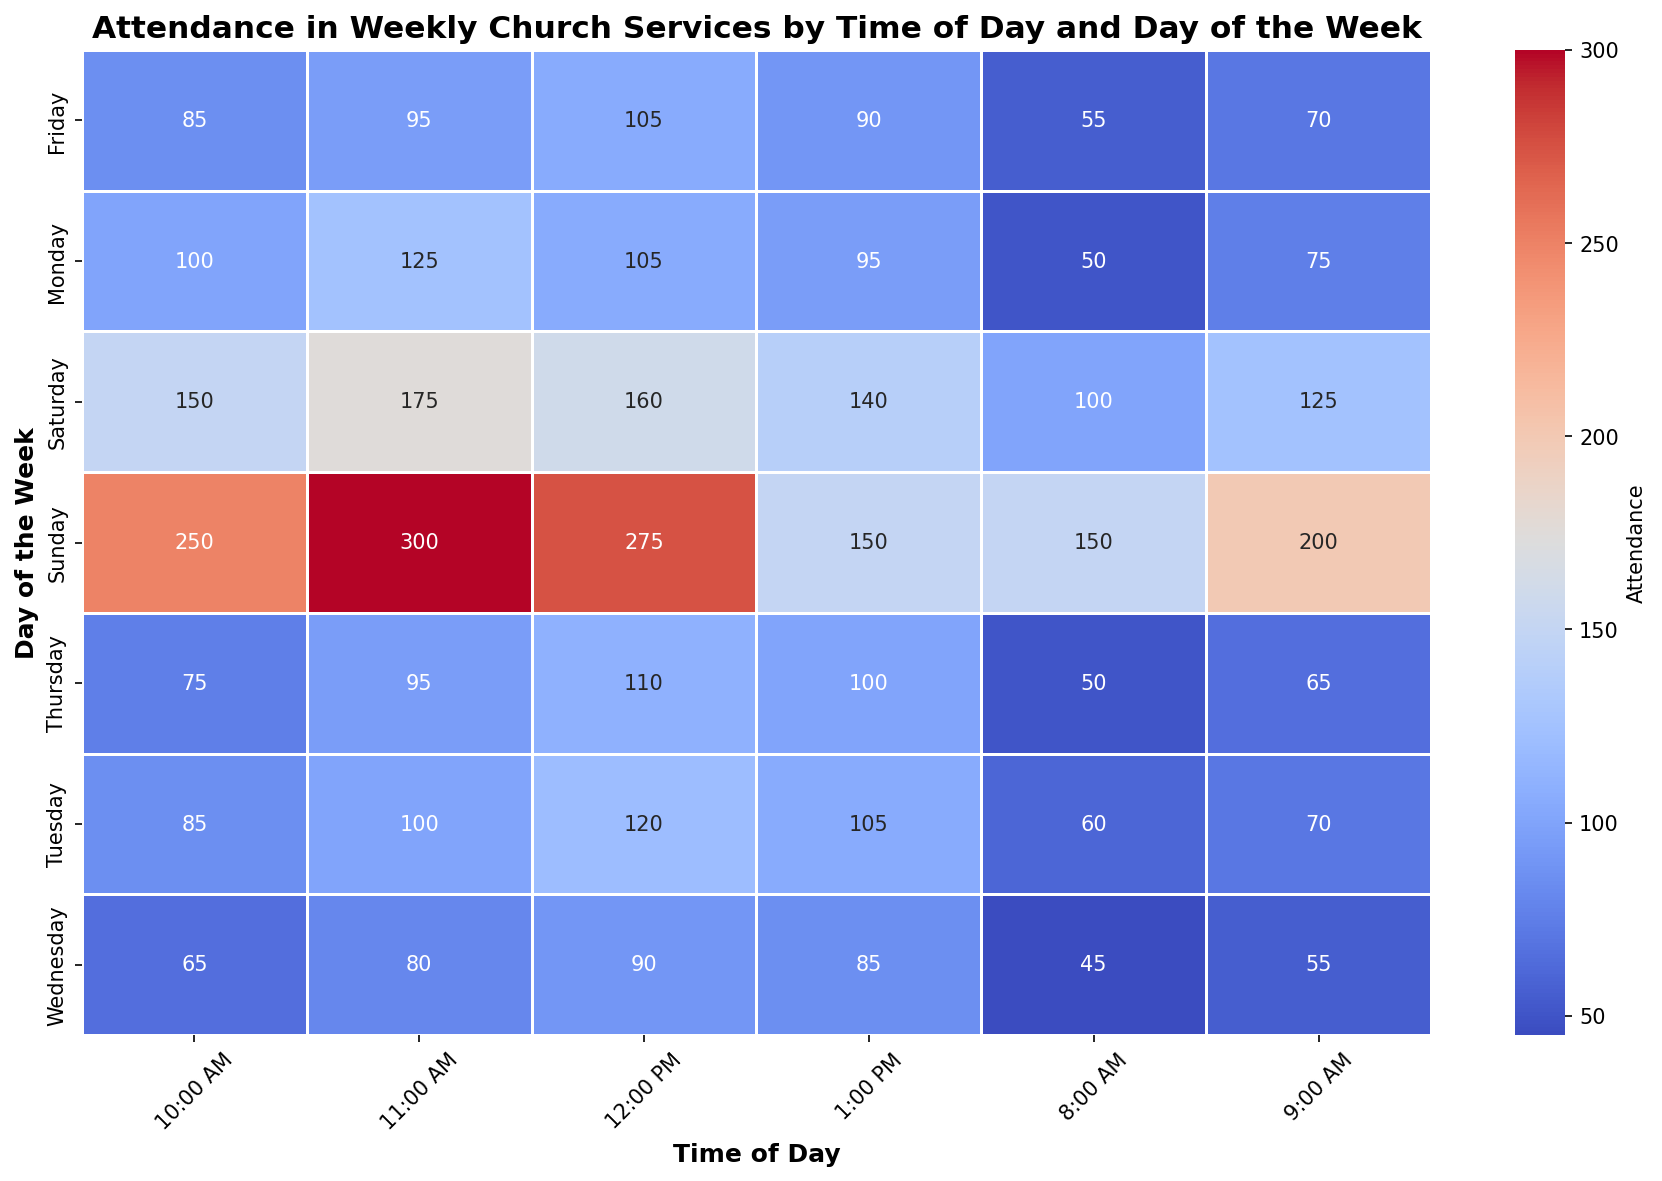What day has the highest attendance overall? To determine the day with the highest overall attendance, sum the attendance for all time slots on each day. The day with the largest total will be the answer.
Answer: Sunday Which time slot on Sunday has the highest attendance? Look at the attendance numbers for each time slot on Sunday and identify the highest.
Answer: 11:00 AM How does the attendance at 10:00 AM on Monday compare to that on Tuesday? Compare the attendance at 10:00 AM on Monday (100 attendees) with the attendance at the same time on Tuesday (85 attendees).
Answer: Monday has higher attendance What is the average attendance at 12:00 PM from Monday to Friday? Add the attendance at 12:00 PM for Monday to Friday (105 + 120 + 90 + 110 + 105) and divide by 5.
Answer: 106 Which day has the lowest attendance at 8:00 AM? Compare the attendance at 8:00 AM across all days and identify the smallest number.
Answer: Wednesday Which time slot has the largest difference in attendance between Sunday and any other day? Look at each time slot on Sunday and determine the maximum difference by comparing with the same time slots on other days. The largest difference can be observed by focusing on the time slot 11:00 AM on Sunday (300) and comparing with the highest value on other days.
Answer: 11:00 AM on Sunday vs any other day What's the total attendance for the 1:00 PM time slots across the week? Sum the attendance for the 1:00 PM slot from Sunday to Saturday (150 + 95 + 105 + 85 + 100 + 90 + 140).
Answer: 765 What is the most frequent attendance range for weekdays (Mon-Fri) at 9:00 AM? Observe the attendance values for 9:00 AM from Monday to Friday (75, 70, 55, 65, 70) and determine the most common range they fall into.
Answer: 70-75 range Which visual color indicates the highest attendance in the heatmap? Look for the color that appears on the highest attendance values.
Answer: Darkest shade (of the chosen color palette) How does the attendance trend change from morning (8:00 AM - 12:00 PM) to afternoon (1:00 PM) on Wednesday? Compare the attendance from 8:00 AM to 12:00 PM on Wednesday and then observe the change at 1:00 PM (8:00 AM: 45, 9:00 AM: 55, 10:00 AM: 65, 11:00 AM: 80, 12:00 PM: 90, 1:00 PM: 85).
Answer: Slight drop at 1:00 PM 